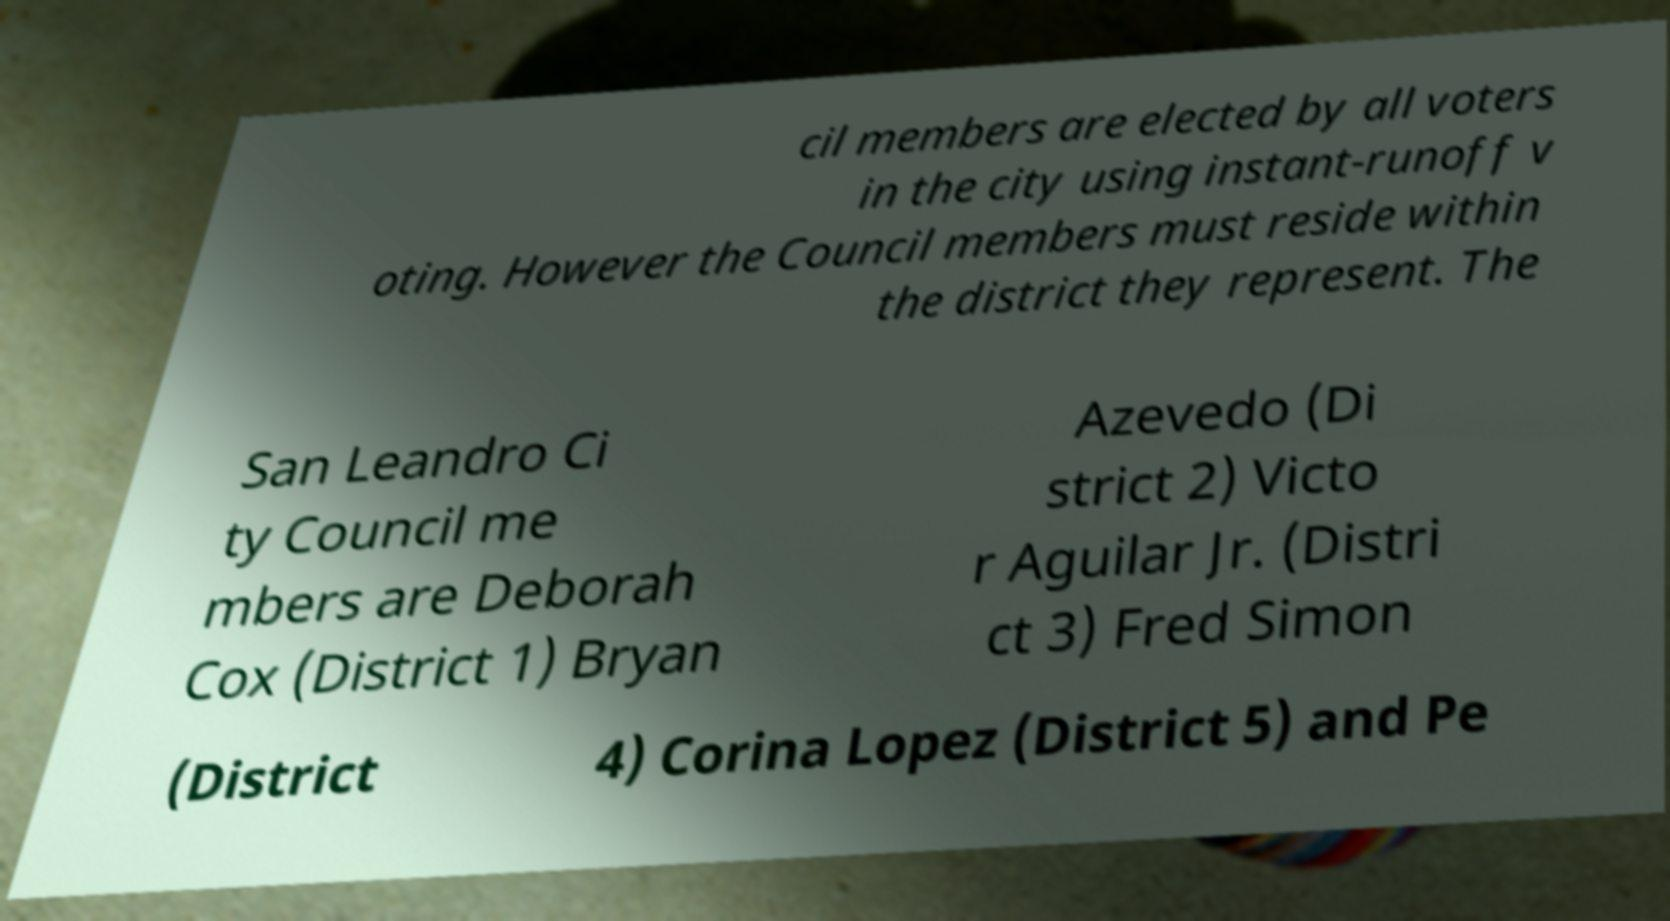For documentation purposes, I need the text within this image transcribed. Could you provide that? cil members are elected by all voters in the city using instant-runoff v oting. However the Council members must reside within the district they represent. The San Leandro Ci ty Council me mbers are Deborah Cox (District 1) Bryan Azevedo (Di strict 2) Victo r Aguilar Jr. (Distri ct 3) Fred Simon (District 4) Corina Lopez (District 5) and Pe 